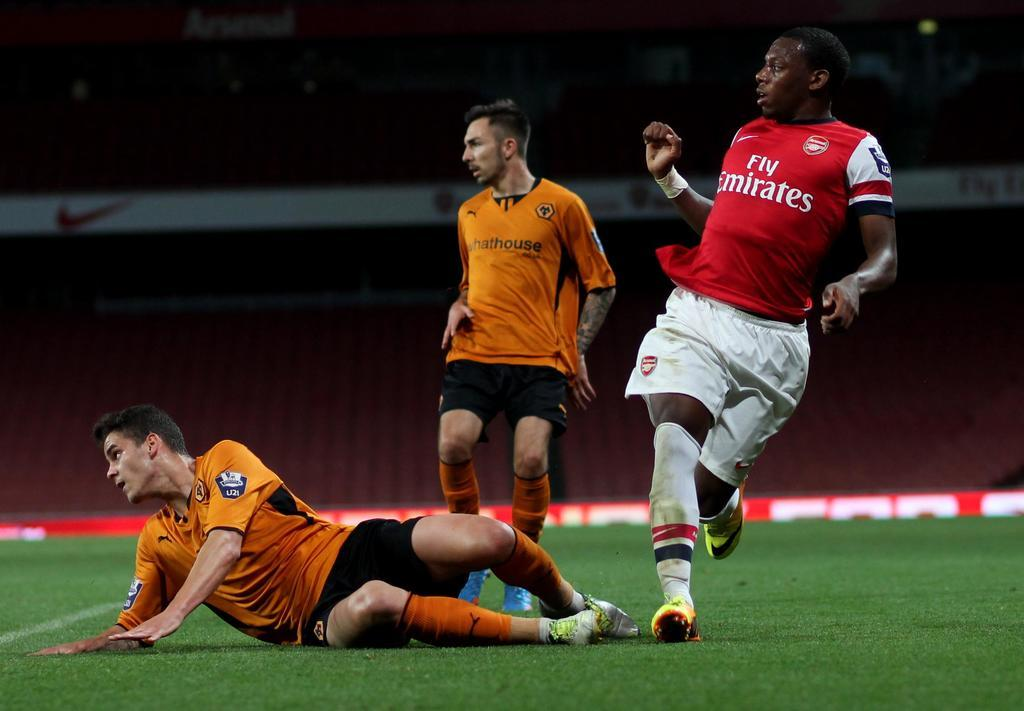<image>
Render a clear and concise summary of the photo. soccer players on a field with one jersey reading fly emirates 